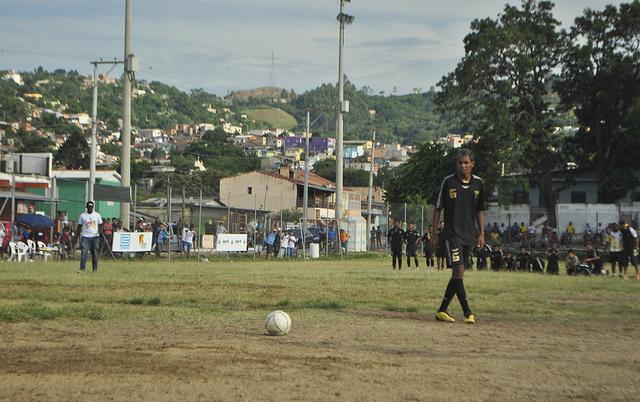What is the man doing?
Answer briefly. Soccer. Where are the kids playing?
Short answer required. Soccer. Is this a farm?
Quick response, please. No. What color are the man's shoes?
Answer briefly. Yellow. Is it wintertime?
Quick response, please. No. What sport is this?
Short answer required. Soccer. 